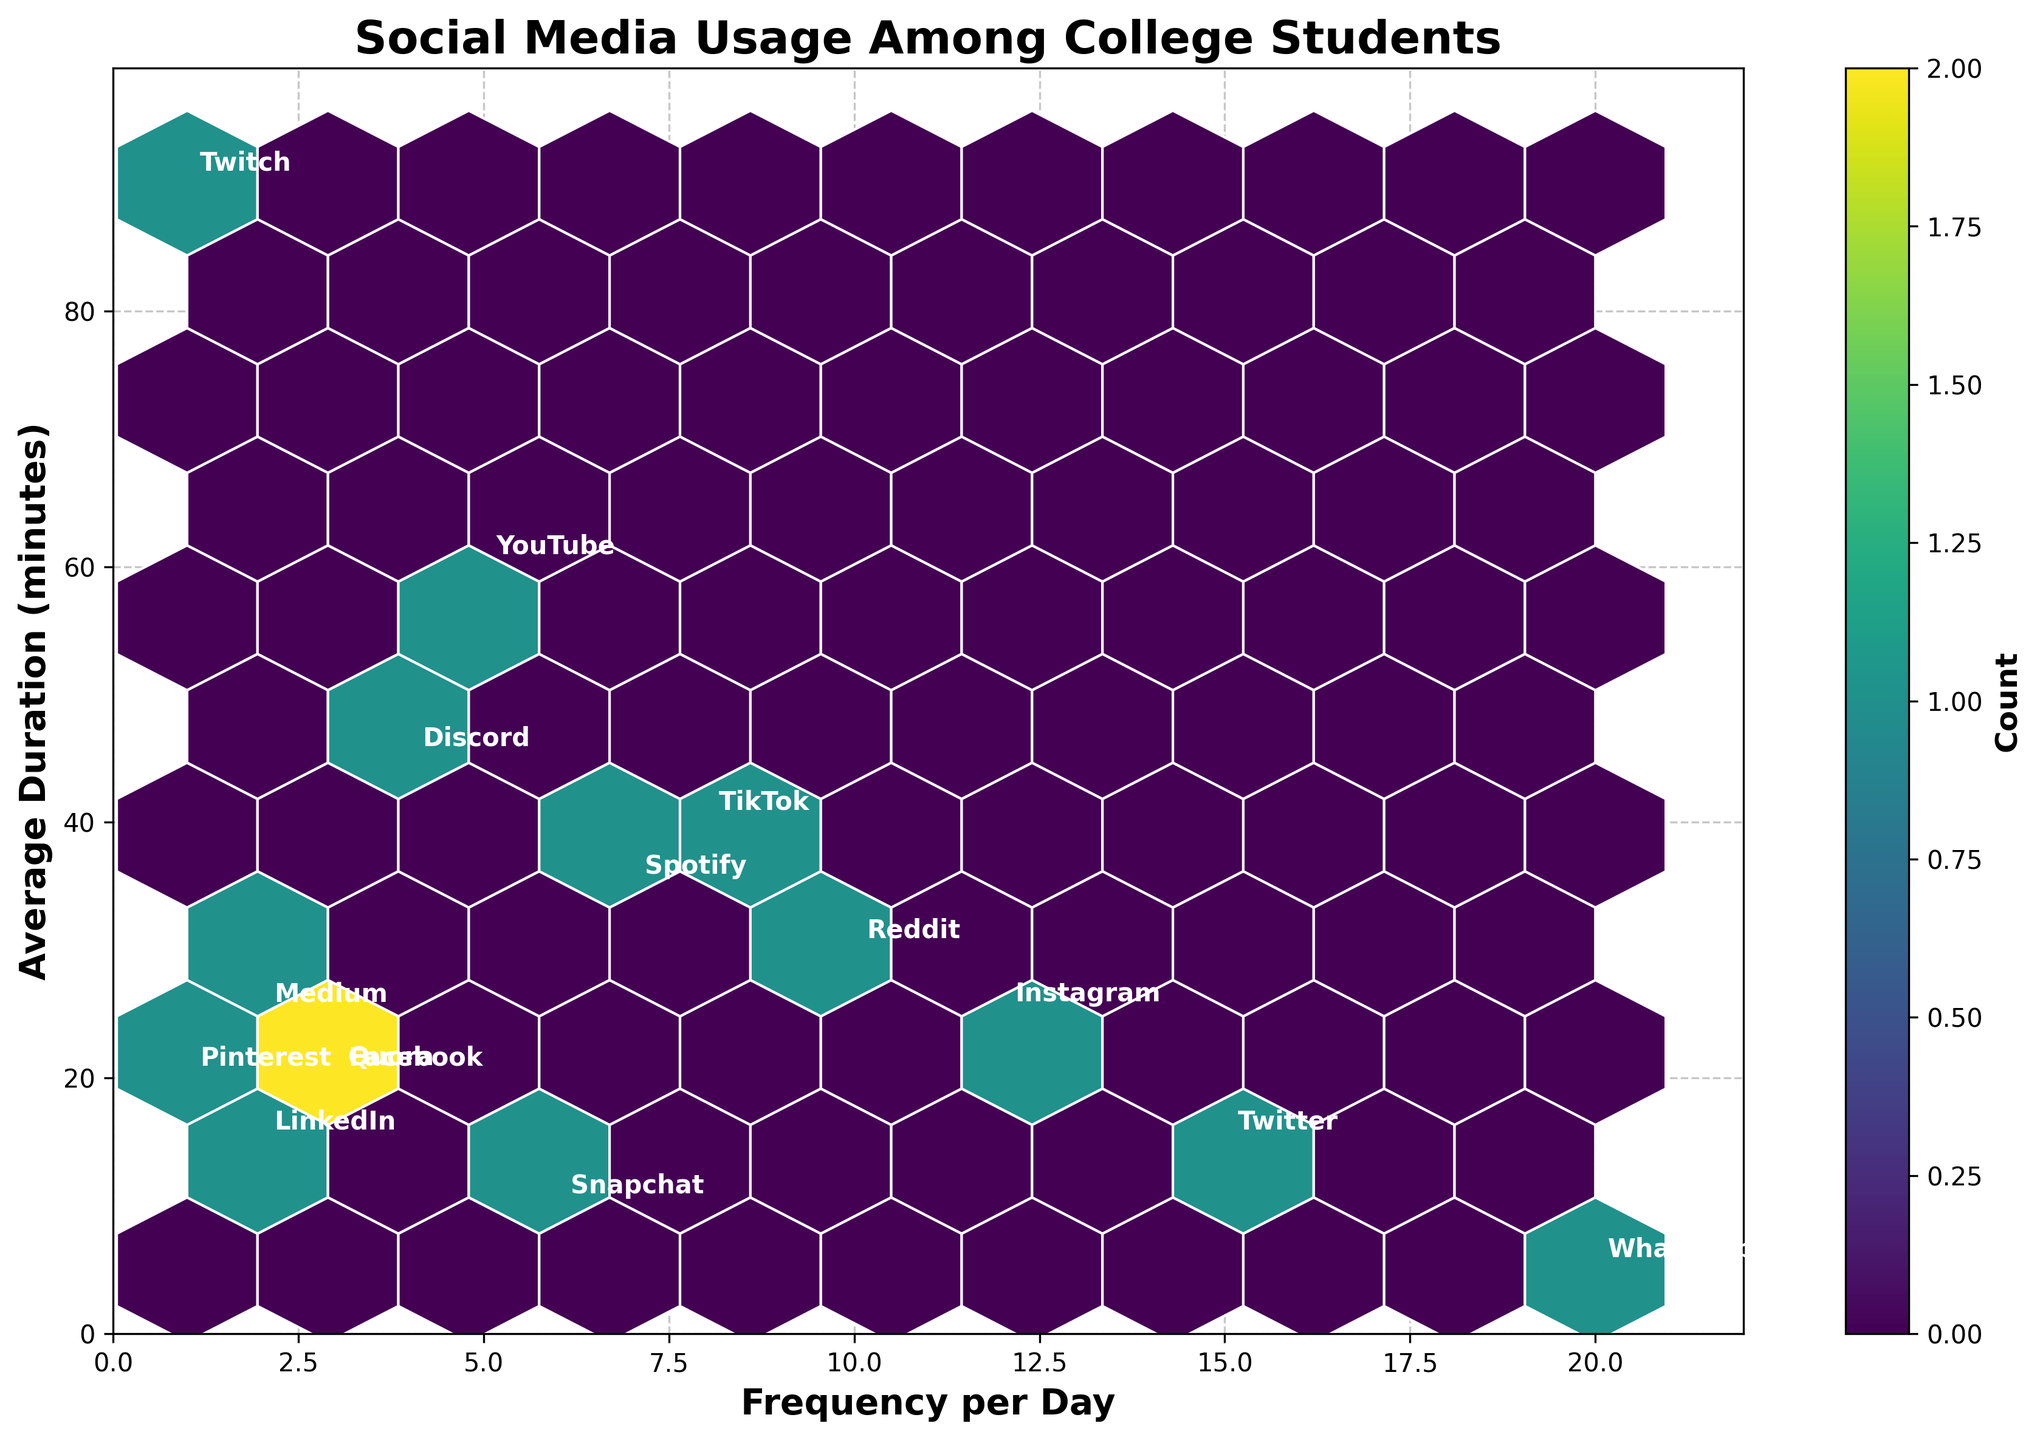What's the title of the figure? The title of the figure is shown at the top and highlights the main topic of the plot.
Answer: Social Media Usage Among College Students What are the labels of the x and y axes? The labels of the axes are crucial for understanding what each axis represents. The x-axis represents "Frequency per Day" while the y-axis represents "Average Duration (minutes)".
Answer: Frequency per Day, Average Duration (minutes) Which platform has the highest frequency of usage per day? By looking at the x-axis and identifying the point farthest to the right, we see that WhatsApp has the highest frequency of usage at 20 times per day.
Answer: WhatsApp Which platform has the highest average duration of use? By looking at the y-axis and finding the point that is highest up, Twitch stands out with an average duration of 90 minutes.
Answer: Twitch How many platforms are represented in the figure? Count the number of unique platforms annotated within the hexbin plot.
Answer: 15 Which platform uses the least amount of time on average while having a moderate frequency of use? By examining both the x and y coordinates, it is evident that WhatsApp has the shortest average duration at 5 minutes but is used frequently at 20 times per day.
Answer: WhatsApp What is the sum of the daily usage frequencies of Instagram and Twitter? Instagram's frequency is 12, and Twitter's is 15. Adding these two values together gives a total frequency of 27.
Answer: 27 Which platforms are used less frequently but have longer average durations of usage? By looking for points that are lower on the x-axis but higher on the y-axis, Discord (4 times/day, 45 minutes) and Twitch (1 time/day, 90 minutes) stand out.
Answer: Discord, Twitch What is the range of frequencies displayed on the x-axis? The range is determined by subtracting the minimum value (1 for Pinterest and Twitch) from the maximum value (20 for WhatsApp).
Answer: 19 How does the use of Instagram compare to Reddit in terms of frequency and duration? Instagram (12 times/day, 25 minutes) is used more frequently than Reddit (10 times/day, 30 minutes) but for a shorter duration.
Answer: Instagram is used more frequently but has a shorter average duration 